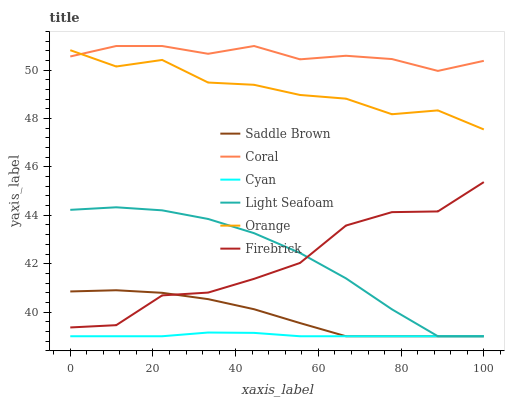Does Cyan have the minimum area under the curve?
Answer yes or no. Yes. Does Coral have the maximum area under the curve?
Answer yes or no. Yes. Does Firebrick have the minimum area under the curve?
Answer yes or no. No. Does Firebrick have the maximum area under the curve?
Answer yes or no. No. Is Cyan the smoothest?
Answer yes or no. Yes. Is Firebrick the roughest?
Answer yes or no. Yes. Is Orange the smoothest?
Answer yes or no. No. Is Orange the roughest?
Answer yes or no. No. Does Cyan have the lowest value?
Answer yes or no. Yes. Does Firebrick have the lowest value?
Answer yes or no. No. Does Coral have the highest value?
Answer yes or no. Yes. Does Firebrick have the highest value?
Answer yes or no. No. Is Light Seafoam less than Coral?
Answer yes or no. Yes. Is Firebrick greater than Cyan?
Answer yes or no. Yes. Does Coral intersect Orange?
Answer yes or no. Yes. Is Coral less than Orange?
Answer yes or no. No. Is Coral greater than Orange?
Answer yes or no. No. Does Light Seafoam intersect Coral?
Answer yes or no. No. 